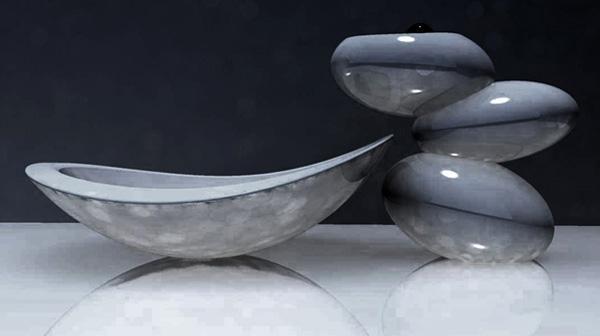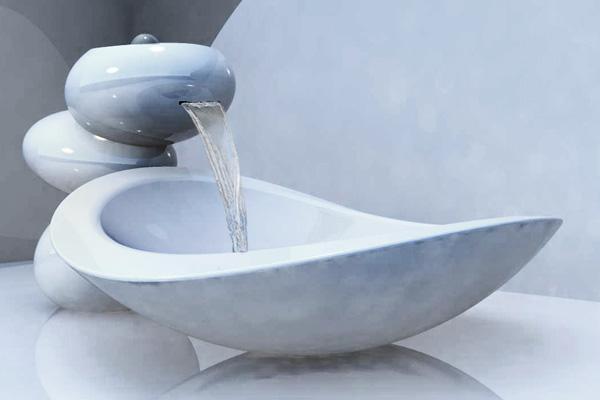The first image is the image on the left, the second image is the image on the right. Considering the images on both sides, is "The left and right image contains the same number of oval sinks." valid? Answer yes or no. Yes. The first image is the image on the left, the second image is the image on the right. Considering the images on both sides, is "In exactly one image water is pouring from the faucet." valid? Answer yes or no. Yes. 